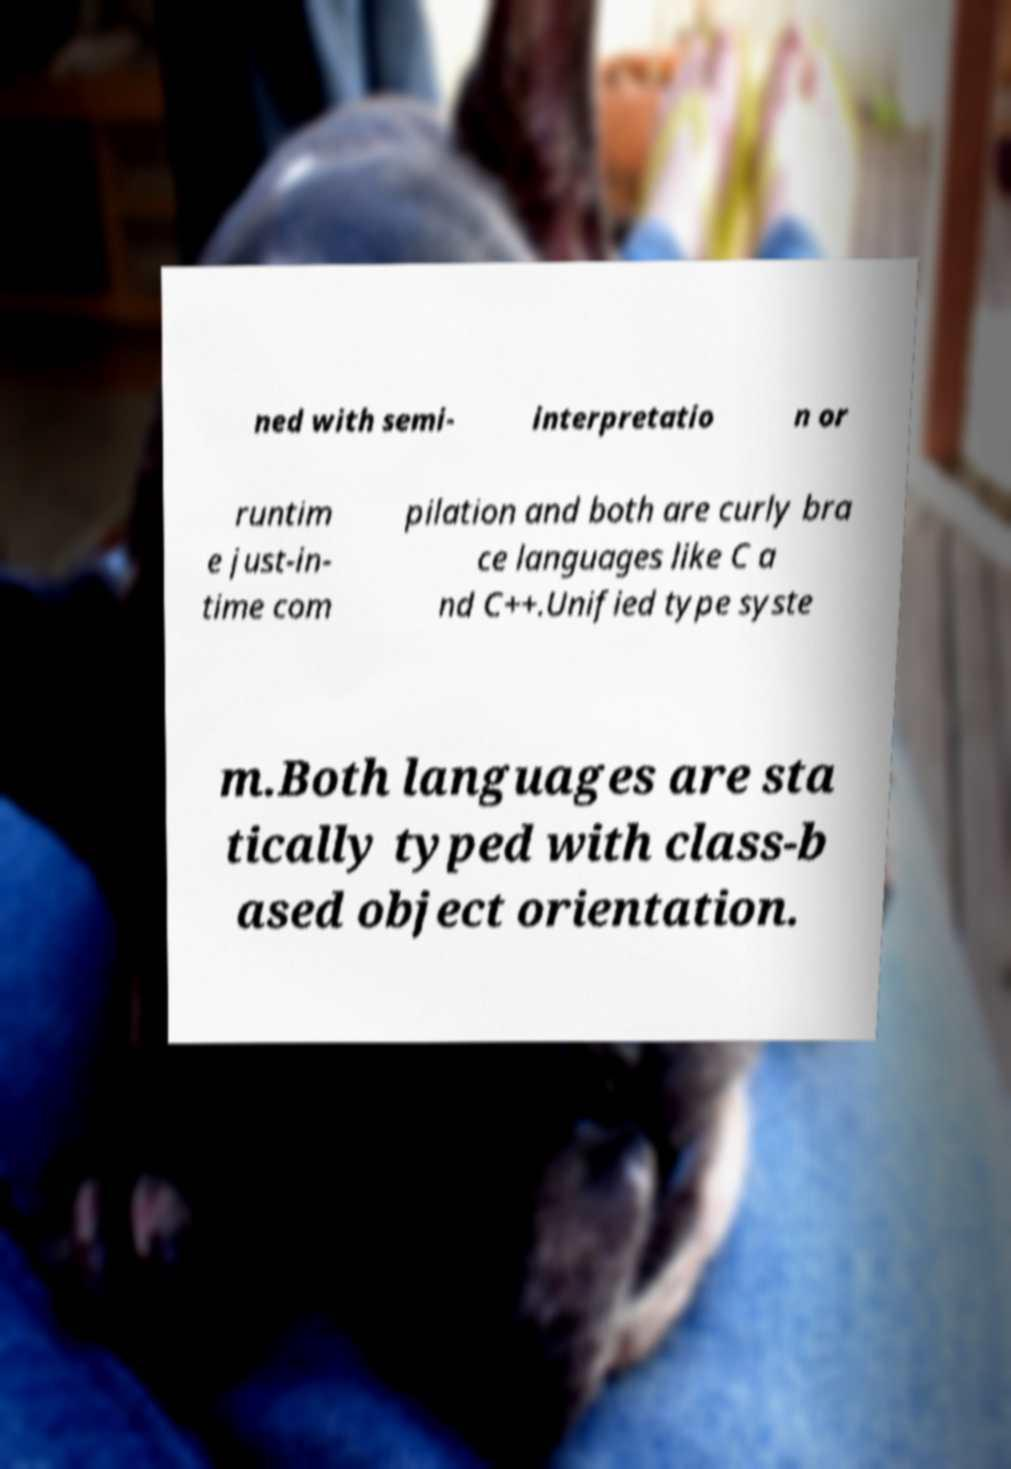I need the written content from this picture converted into text. Can you do that? ned with semi- interpretatio n or runtim e just-in- time com pilation and both are curly bra ce languages like C a nd C++.Unified type syste m.Both languages are sta tically typed with class-b ased object orientation. 